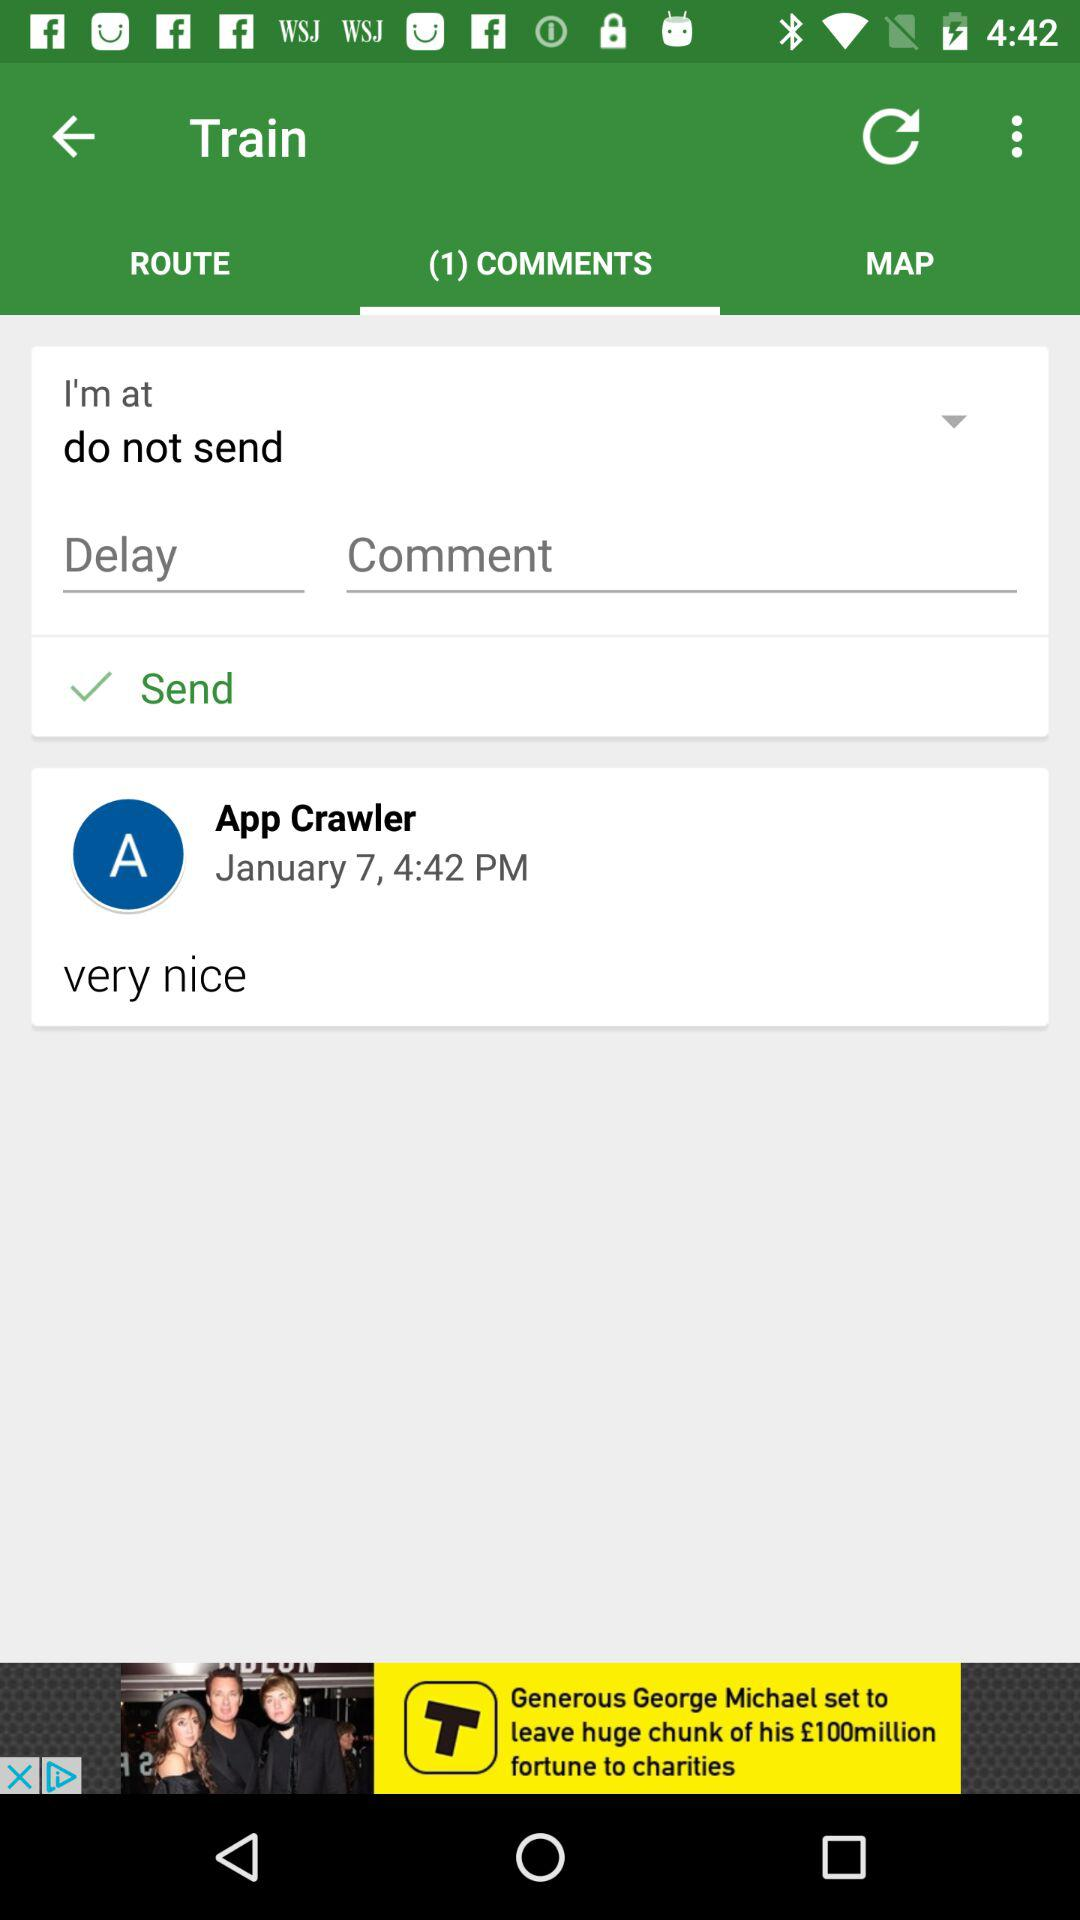What is the profile name? The profile name is App Crawler. 